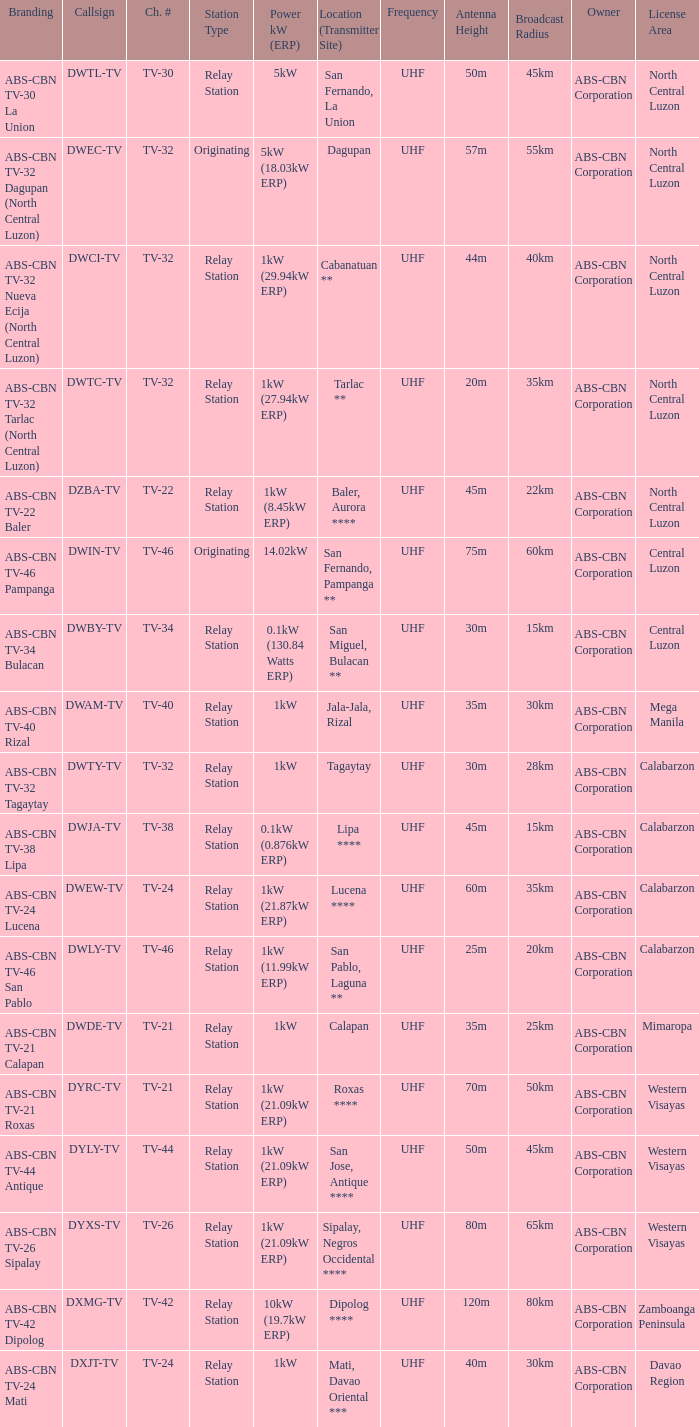What is the branding of the callsign DWCI-TV? ABS-CBN TV-32 Nueva Ecija (North Central Luzon). 